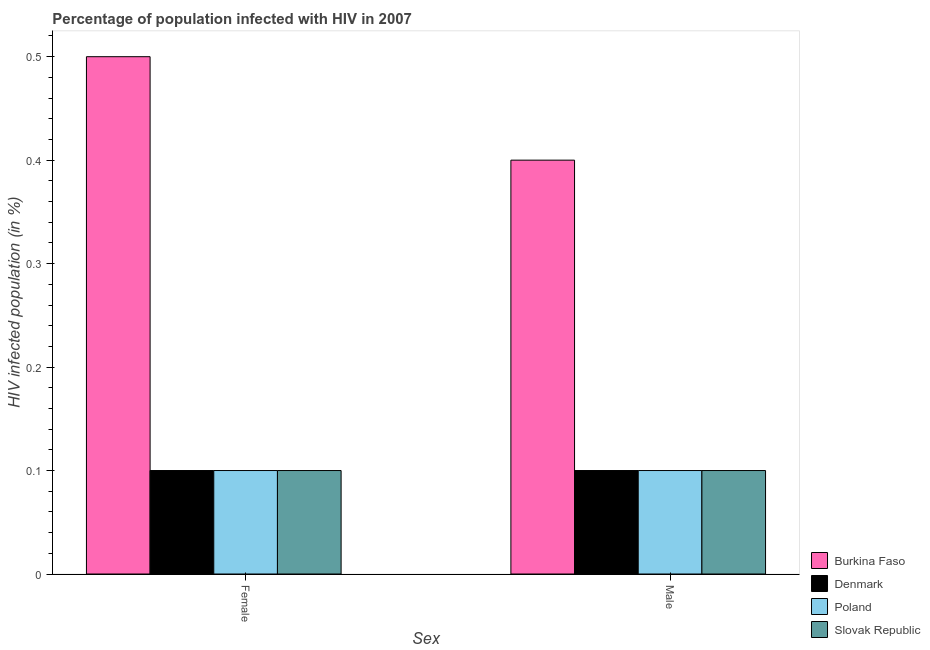How many different coloured bars are there?
Offer a terse response. 4. How many groups of bars are there?
Ensure brevity in your answer.  2. Are the number of bars per tick equal to the number of legend labels?
Offer a very short reply. Yes. Are the number of bars on each tick of the X-axis equal?
Offer a very short reply. Yes. How many bars are there on the 1st tick from the left?
Offer a terse response. 4. What is the percentage of males who are infected with hiv in Slovak Republic?
Provide a short and direct response. 0.1. Across all countries, what is the maximum percentage of males who are infected with hiv?
Your answer should be very brief. 0.4. In which country was the percentage of males who are infected with hiv maximum?
Provide a short and direct response. Burkina Faso. In which country was the percentage of females who are infected with hiv minimum?
Offer a very short reply. Denmark. What is the total percentage of females who are infected with hiv in the graph?
Ensure brevity in your answer.  0.8. What is the difference between the percentage of females who are infected with hiv in Slovak Republic and that in Burkina Faso?
Make the answer very short. -0.4. What is the difference between the percentage of males who are infected with hiv in Denmark and the percentage of females who are infected with hiv in Poland?
Give a very brief answer. 0. What is the average percentage of males who are infected with hiv per country?
Your answer should be compact. 0.17. What is the difference between the percentage of females who are infected with hiv and percentage of males who are infected with hiv in Slovak Republic?
Your answer should be very brief. 0. In how many countries, is the percentage of males who are infected with hiv greater than 0.30000000000000004 %?
Keep it short and to the point. 1. What does the 1st bar from the left in Male represents?
Provide a succinct answer. Burkina Faso. What does the 4th bar from the right in Male represents?
Offer a terse response. Burkina Faso. How many countries are there in the graph?
Your answer should be compact. 4. Does the graph contain any zero values?
Ensure brevity in your answer.  No. What is the title of the graph?
Your answer should be compact. Percentage of population infected with HIV in 2007. What is the label or title of the X-axis?
Your answer should be very brief. Sex. What is the label or title of the Y-axis?
Your answer should be compact. HIV infected population (in %). What is the HIV infected population (in %) of Denmark in Female?
Your response must be concise. 0.1. What is the HIV infected population (in %) of Slovak Republic in Female?
Your response must be concise. 0.1. What is the HIV infected population (in %) in Poland in Male?
Keep it short and to the point. 0.1. What is the HIV infected population (in %) in Slovak Republic in Male?
Offer a very short reply. 0.1. Across all Sex, what is the maximum HIV infected population (in %) of Slovak Republic?
Give a very brief answer. 0.1. Across all Sex, what is the minimum HIV infected population (in %) of Burkina Faso?
Give a very brief answer. 0.4. Across all Sex, what is the minimum HIV infected population (in %) of Denmark?
Make the answer very short. 0.1. Across all Sex, what is the minimum HIV infected population (in %) of Poland?
Provide a short and direct response. 0.1. Across all Sex, what is the minimum HIV infected population (in %) in Slovak Republic?
Provide a succinct answer. 0.1. What is the total HIV infected population (in %) of Poland in the graph?
Your answer should be very brief. 0.2. What is the difference between the HIV infected population (in %) of Slovak Republic in Female and that in Male?
Provide a succinct answer. 0. What is the difference between the HIV infected population (in %) in Burkina Faso in Female and the HIV infected population (in %) in Poland in Male?
Provide a short and direct response. 0.4. What is the difference between the HIV infected population (in %) of Denmark in Female and the HIV infected population (in %) of Poland in Male?
Provide a succinct answer. 0. What is the difference between the HIV infected population (in %) in Denmark in Female and the HIV infected population (in %) in Slovak Republic in Male?
Ensure brevity in your answer.  0. What is the average HIV infected population (in %) of Burkina Faso per Sex?
Provide a succinct answer. 0.45. What is the average HIV infected population (in %) of Denmark per Sex?
Provide a short and direct response. 0.1. What is the difference between the HIV infected population (in %) in Burkina Faso and HIV infected population (in %) in Denmark in Female?
Keep it short and to the point. 0.4. What is the difference between the HIV infected population (in %) of Burkina Faso and HIV infected population (in %) of Poland in Female?
Keep it short and to the point. 0.4. What is the difference between the HIV infected population (in %) of Denmark and HIV infected population (in %) of Poland in Female?
Give a very brief answer. 0. What is the difference between the HIV infected population (in %) in Poland and HIV infected population (in %) in Slovak Republic in Female?
Your response must be concise. 0. What is the difference between the HIV infected population (in %) of Burkina Faso and HIV infected population (in %) of Poland in Male?
Keep it short and to the point. 0.3. What is the difference between the HIV infected population (in %) of Denmark and HIV infected population (in %) of Poland in Male?
Offer a very short reply. 0. What is the ratio of the HIV infected population (in %) of Burkina Faso in Female to that in Male?
Give a very brief answer. 1.25. What is the ratio of the HIV infected population (in %) in Denmark in Female to that in Male?
Your answer should be very brief. 1. What is the ratio of the HIV infected population (in %) in Poland in Female to that in Male?
Your answer should be very brief. 1. What is the difference between the highest and the second highest HIV infected population (in %) of Burkina Faso?
Ensure brevity in your answer.  0.1. What is the difference between the highest and the second highest HIV infected population (in %) in Denmark?
Your answer should be very brief. 0. What is the difference between the highest and the second highest HIV infected population (in %) of Poland?
Provide a succinct answer. 0. What is the difference between the highest and the second highest HIV infected population (in %) in Slovak Republic?
Your answer should be compact. 0. What is the difference between the highest and the lowest HIV infected population (in %) in Poland?
Your answer should be compact. 0. 